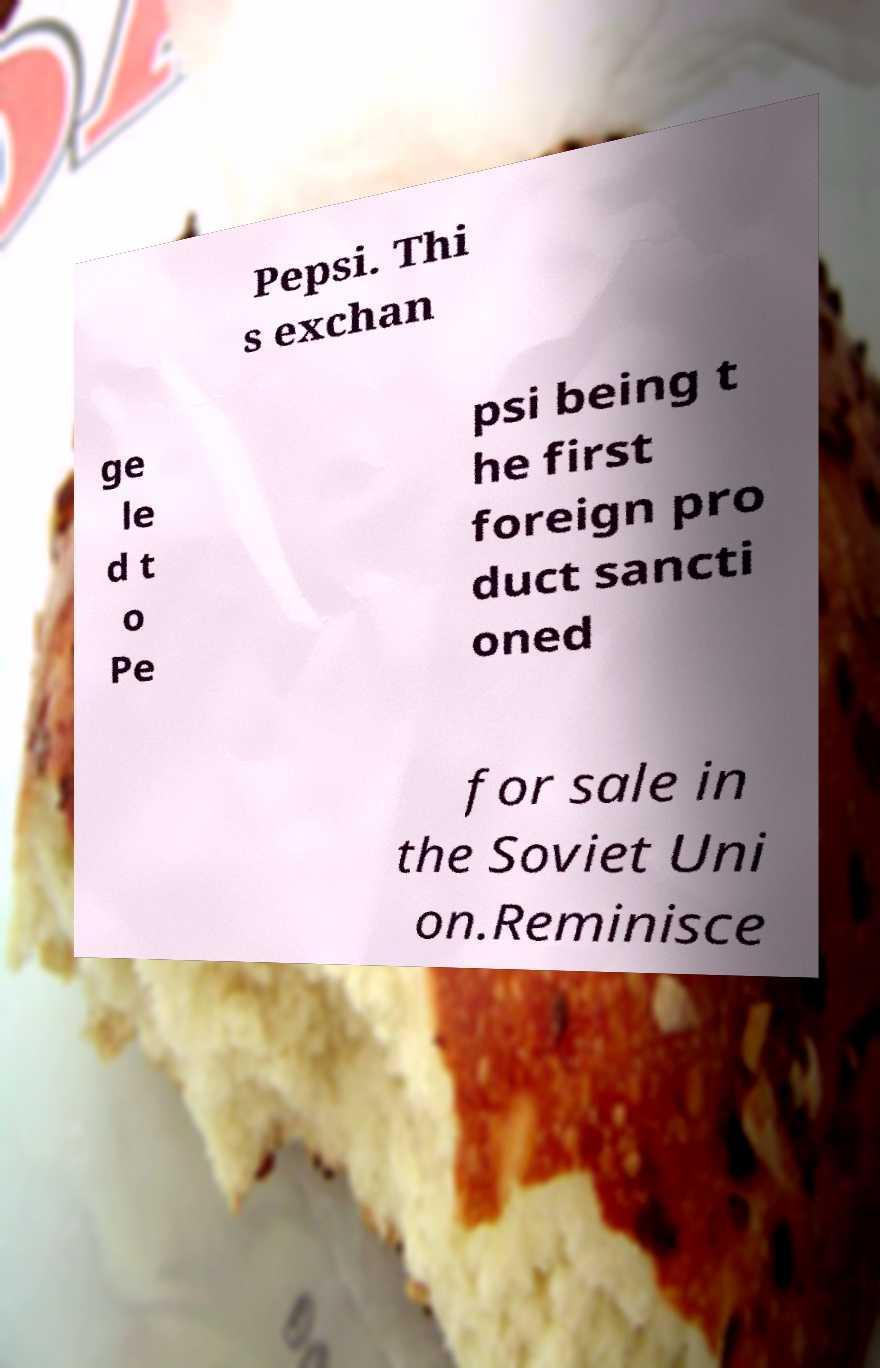Please identify and transcribe the text found in this image. Pepsi. Thi s exchan ge le d t o Pe psi being t he first foreign pro duct sancti oned for sale in the Soviet Uni on.Reminisce 